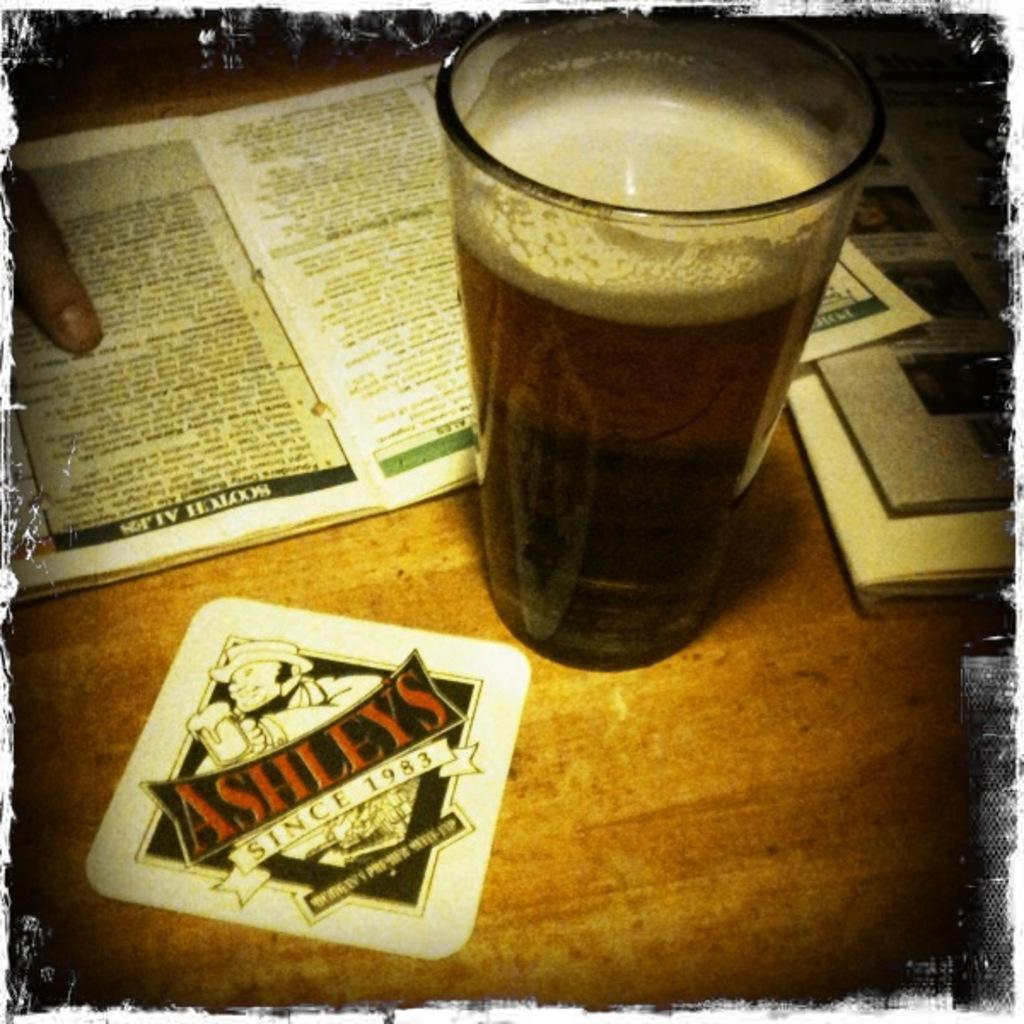<image>
Offer a succinct explanation of the picture presented. A bottle of beer is on a table by an Ashley's coaster that says since 1983. 